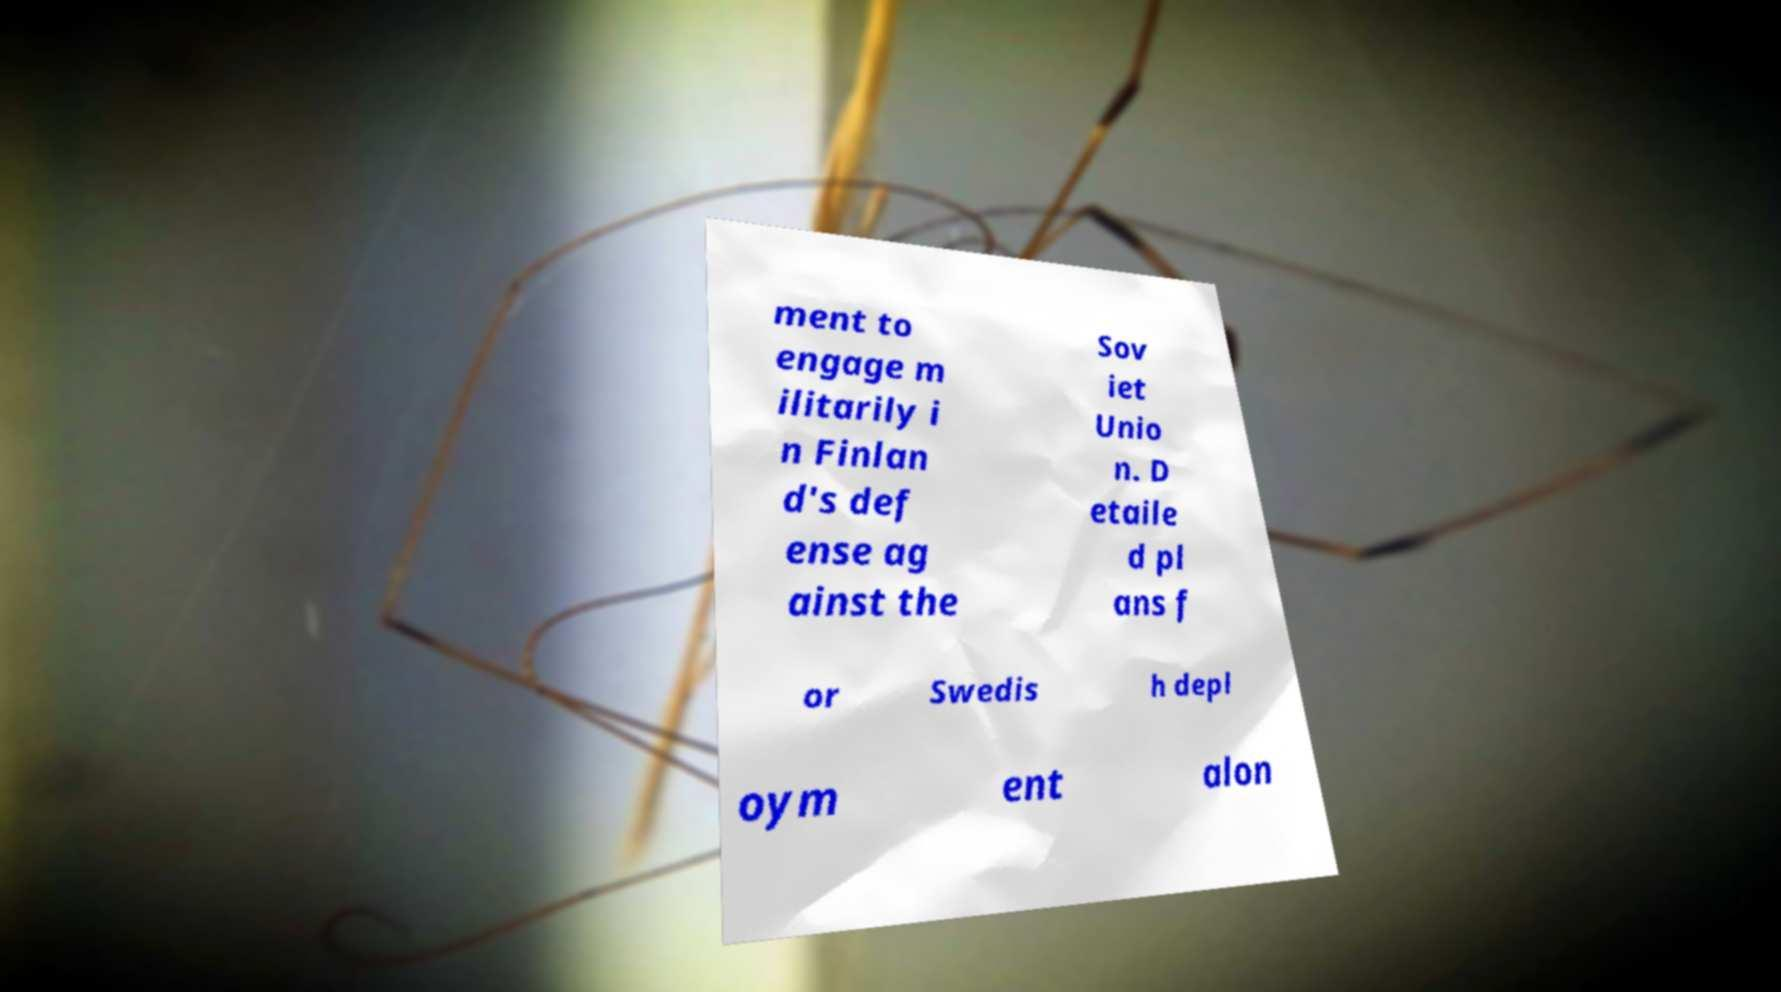There's text embedded in this image that I need extracted. Can you transcribe it verbatim? ment to engage m ilitarily i n Finlan d's def ense ag ainst the Sov iet Unio n. D etaile d pl ans f or Swedis h depl oym ent alon 